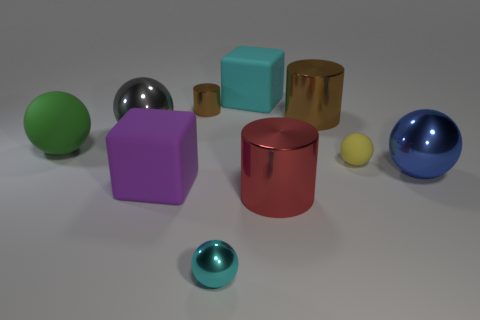There is a metal ball on the right side of the big brown shiny cylinder; what color is it?
Your answer should be very brief. Blue. There is a brown metallic cylinder that is to the right of the tiny metallic object that is on the left side of the small cyan ball; is there a metal thing that is on the left side of it?
Ensure brevity in your answer.  Yes. Is the number of gray shiny objects to the right of the big gray thing greater than the number of small yellow shiny balls?
Provide a succinct answer. No. There is a small shiny thing in front of the green sphere; is it the same shape as the large green object?
Your answer should be compact. Yes. Are there any other things that are the same material as the purple object?
Provide a short and direct response. Yes. What number of objects are small cyan matte cubes or things in front of the large cyan object?
Your answer should be compact. 9. There is a matte object that is both behind the tiny yellow matte thing and in front of the big cyan rubber object; what size is it?
Provide a short and direct response. Large. Are there more small yellow spheres behind the tiny yellow rubber ball than big rubber blocks behind the green rubber thing?
Provide a succinct answer. No. Is the shape of the big blue object the same as the brown shiny object in front of the tiny brown metal thing?
Offer a very short reply. No. How many other things are the same shape as the tiny rubber thing?
Your answer should be compact. 4. 